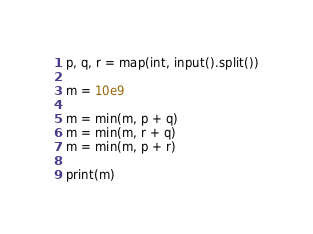Convert code to text. <code><loc_0><loc_0><loc_500><loc_500><_Python_>p, q, r = map(int, input().split())
 
m = 10e9
 
m = min(m, p + q)
m = min(m, r + q)
m = min(m, p + r)
 
print(m)</code> 